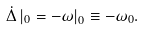<formula> <loc_0><loc_0><loc_500><loc_500>\dot { \Delta } \left | _ { 0 } = - \omega \right | _ { 0 } \equiv - \omega _ { 0 } .</formula> 